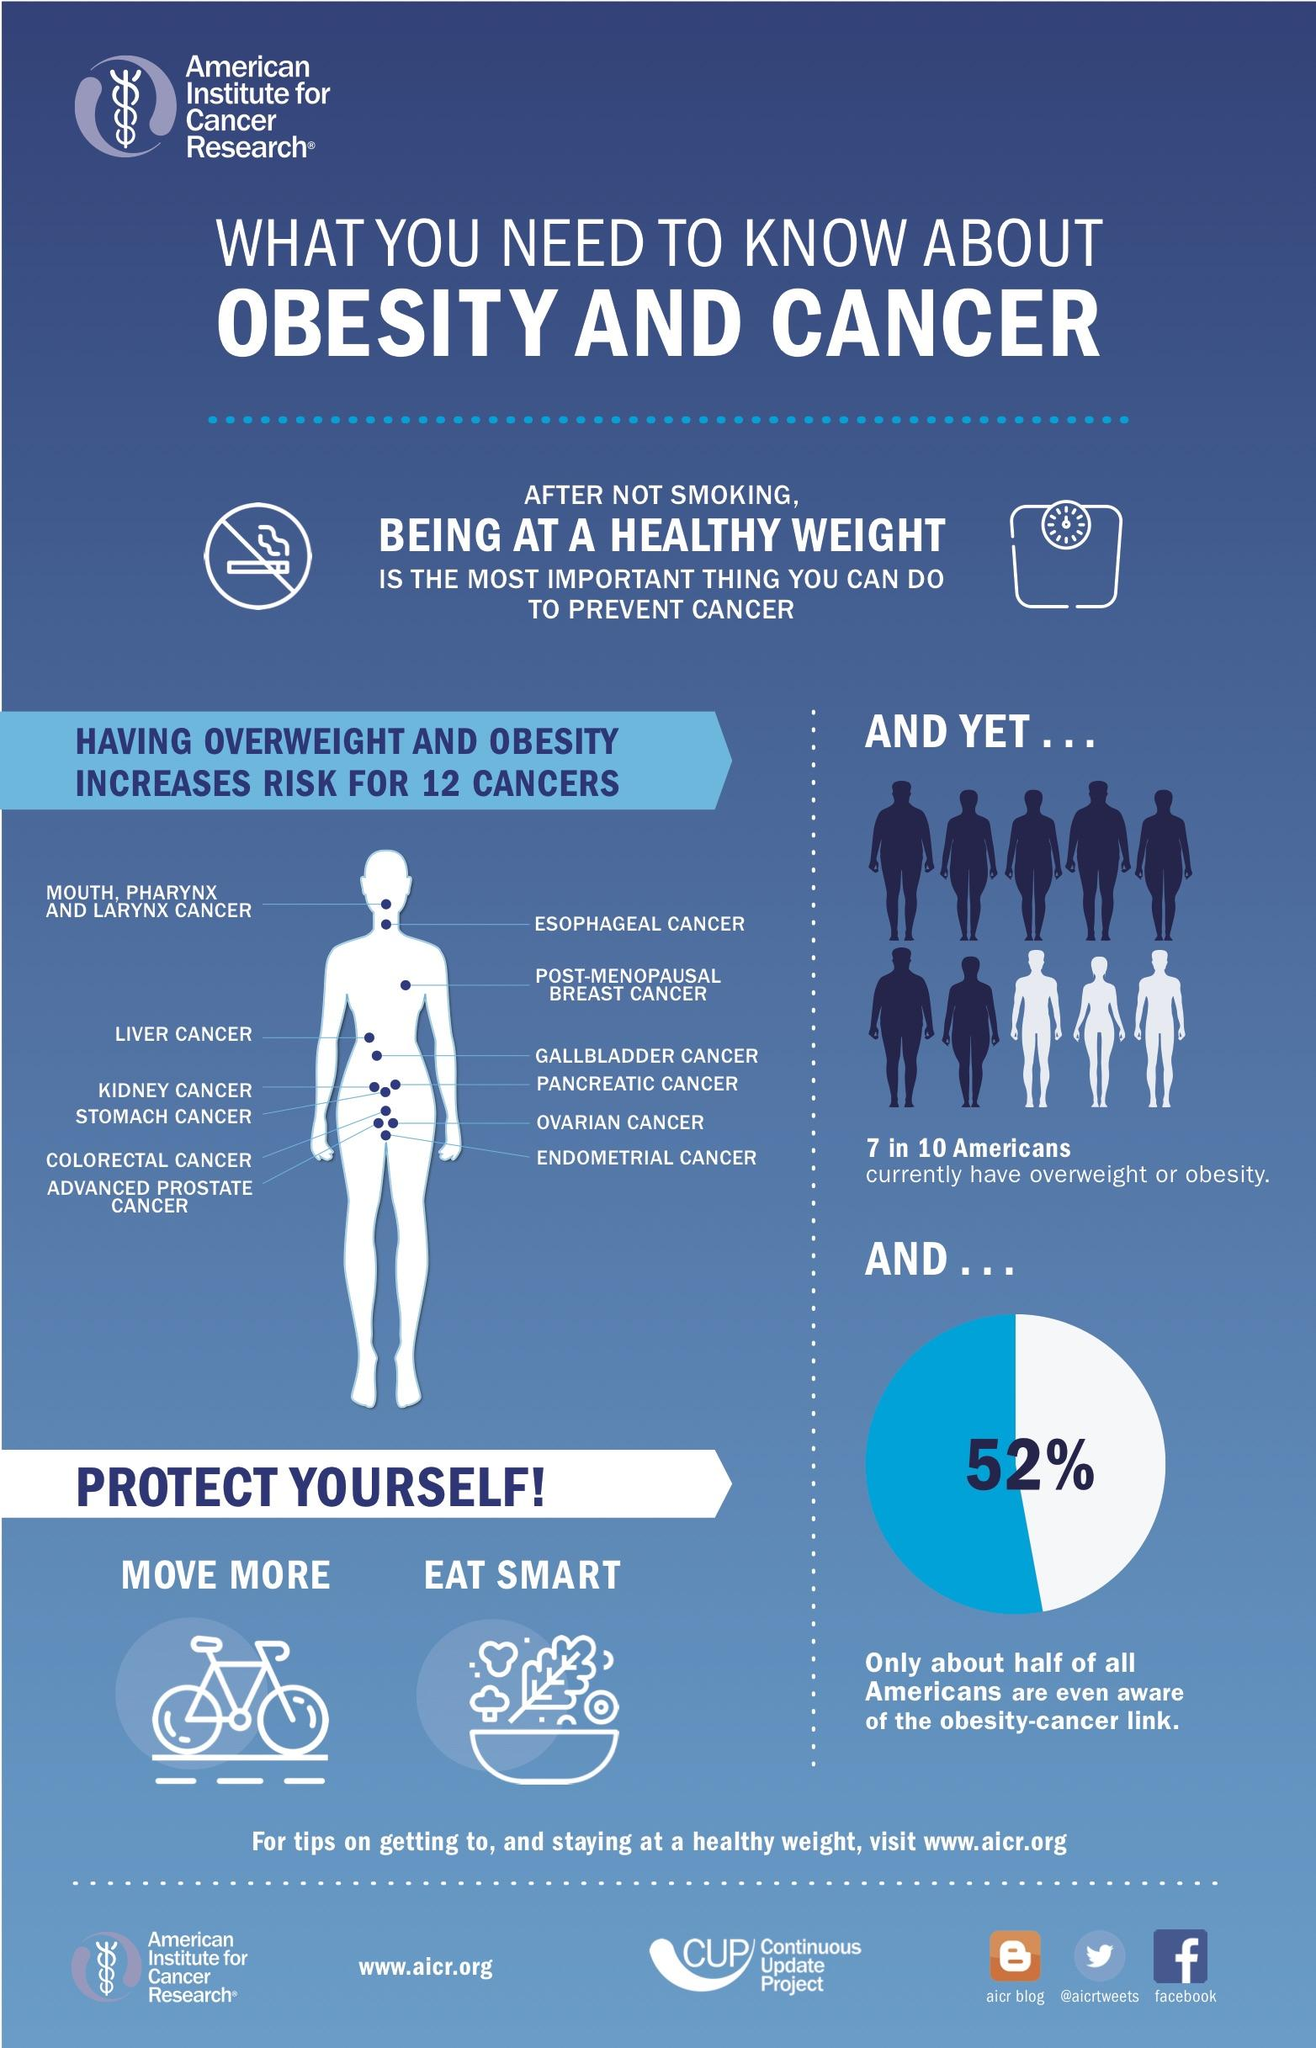Point out several critical features in this image. Healthy weight is the second most important factor in preventing cancer. Smoking is the most significant factor in preventing cancer. According to a recent study, 48% of Americans are unaware of the link between obesity and cancer. Out of 10 Americans, only 3 are not overweighted. 